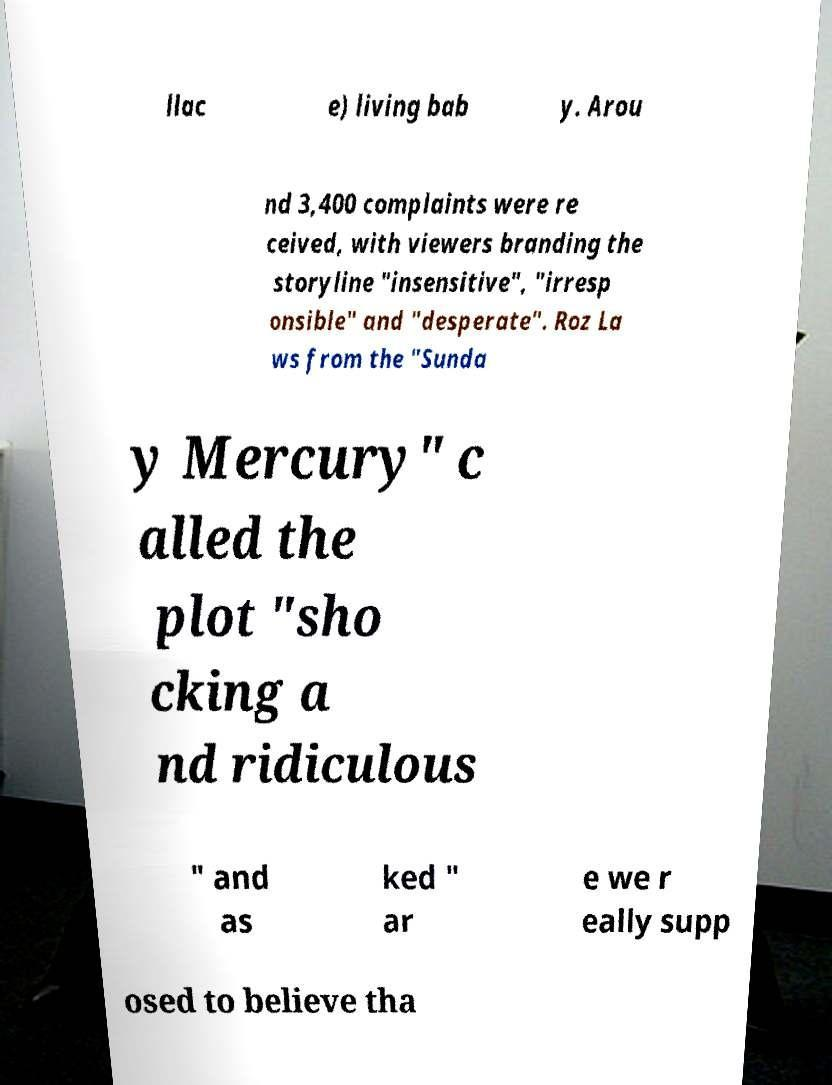For documentation purposes, I need the text within this image transcribed. Could you provide that? llac e) living bab y. Arou nd 3,400 complaints were re ceived, with viewers branding the storyline "insensitive", "irresp onsible" and "desperate". Roz La ws from the "Sunda y Mercury" c alled the plot "sho cking a nd ridiculous " and as ked " ar e we r eally supp osed to believe tha 